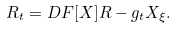Convert formula to latex. <formula><loc_0><loc_0><loc_500><loc_500>R _ { t } = D F [ X ] R - g _ { t } X _ { \xi } .</formula> 